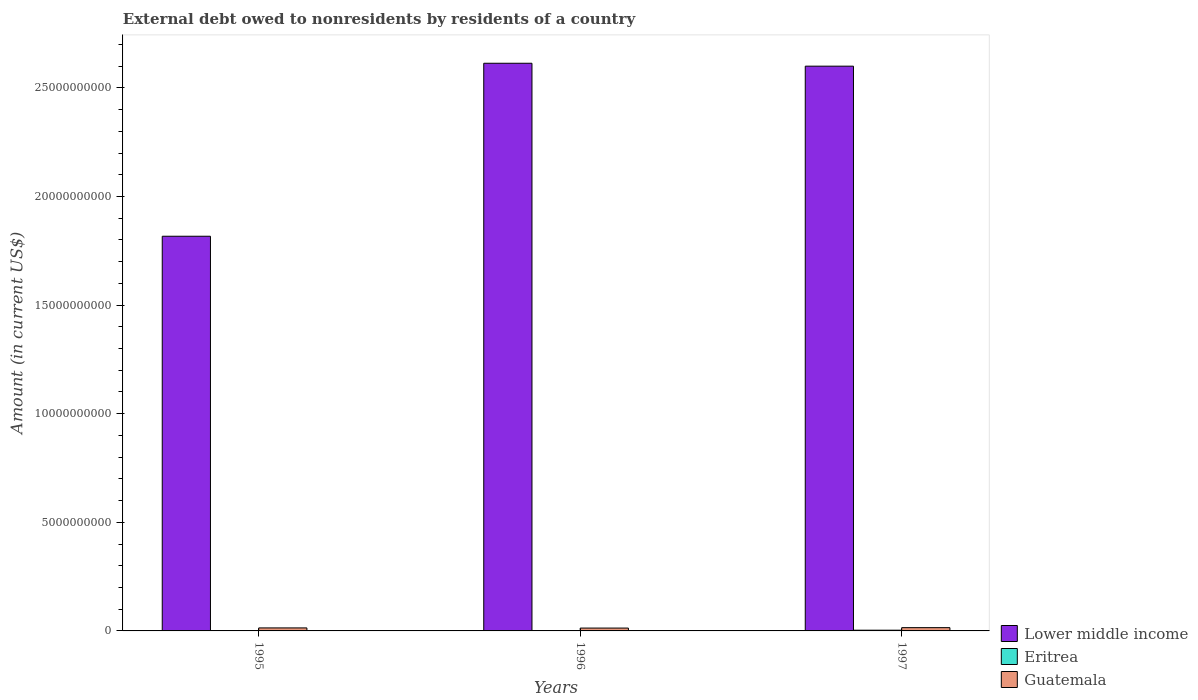How many groups of bars are there?
Your response must be concise. 3. Are the number of bars per tick equal to the number of legend labels?
Make the answer very short. Yes. How many bars are there on the 3rd tick from the left?
Your answer should be compact. 3. How many bars are there on the 2nd tick from the right?
Provide a short and direct response. 3. In how many cases, is the number of bars for a given year not equal to the number of legend labels?
Provide a short and direct response. 0. What is the external debt owed by residents in Guatemala in 1997?
Offer a terse response. 1.51e+08. Across all years, what is the maximum external debt owed by residents in Eritrea?
Give a very brief answer. 3.33e+07. Across all years, what is the minimum external debt owed by residents in Eritrea?
Keep it short and to the point. 6.93e+06. What is the total external debt owed by residents in Lower middle income in the graph?
Your answer should be compact. 7.03e+1. What is the difference between the external debt owed by residents in Lower middle income in 1995 and that in 1996?
Make the answer very short. -7.96e+09. What is the difference between the external debt owed by residents in Lower middle income in 1997 and the external debt owed by residents in Guatemala in 1995?
Give a very brief answer. 2.59e+1. What is the average external debt owed by residents in Lower middle income per year?
Give a very brief answer. 2.34e+1. In the year 1996, what is the difference between the external debt owed by residents in Lower middle income and external debt owed by residents in Eritrea?
Offer a terse response. 2.61e+1. What is the ratio of the external debt owed by residents in Guatemala in 1995 to that in 1997?
Make the answer very short. 0.92. What is the difference between the highest and the second highest external debt owed by residents in Lower middle income?
Provide a short and direct response. 1.34e+08. What is the difference between the highest and the lowest external debt owed by residents in Eritrea?
Provide a short and direct response. 2.64e+07. In how many years, is the external debt owed by residents in Lower middle income greater than the average external debt owed by residents in Lower middle income taken over all years?
Offer a very short reply. 2. Is the sum of the external debt owed by residents in Lower middle income in 1996 and 1997 greater than the maximum external debt owed by residents in Guatemala across all years?
Provide a short and direct response. Yes. What does the 2nd bar from the left in 1997 represents?
Ensure brevity in your answer.  Eritrea. What does the 1st bar from the right in 1996 represents?
Your response must be concise. Guatemala. Is it the case that in every year, the sum of the external debt owed by residents in Lower middle income and external debt owed by residents in Guatemala is greater than the external debt owed by residents in Eritrea?
Offer a terse response. Yes. How many years are there in the graph?
Give a very brief answer. 3. Are the values on the major ticks of Y-axis written in scientific E-notation?
Ensure brevity in your answer.  No. Does the graph contain grids?
Make the answer very short. No. What is the title of the graph?
Give a very brief answer. External debt owed to nonresidents by residents of a country. What is the label or title of the X-axis?
Your answer should be compact. Years. What is the label or title of the Y-axis?
Give a very brief answer. Amount (in current US$). What is the Amount (in current US$) of Lower middle income in 1995?
Your response must be concise. 1.82e+1. What is the Amount (in current US$) in Eritrea in 1995?
Your answer should be compact. 7.22e+06. What is the Amount (in current US$) of Guatemala in 1995?
Your response must be concise. 1.39e+08. What is the Amount (in current US$) in Lower middle income in 1996?
Keep it short and to the point. 2.61e+1. What is the Amount (in current US$) in Eritrea in 1996?
Offer a terse response. 6.93e+06. What is the Amount (in current US$) in Guatemala in 1996?
Provide a short and direct response. 1.31e+08. What is the Amount (in current US$) in Lower middle income in 1997?
Keep it short and to the point. 2.60e+1. What is the Amount (in current US$) of Eritrea in 1997?
Keep it short and to the point. 3.33e+07. What is the Amount (in current US$) of Guatemala in 1997?
Offer a very short reply. 1.51e+08. Across all years, what is the maximum Amount (in current US$) in Lower middle income?
Your response must be concise. 2.61e+1. Across all years, what is the maximum Amount (in current US$) in Eritrea?
Offer a very short reply. 3.33e+07. Across all years, what is the maximum Amount (in current US$) in Guatemala?
Offer a very short reply. 1.51e+08. Across all years, what is the minimum Amount (in current US$) in Lower middle income?
Your answer should be compact. 1.82e+1. Across all years, what is the minimum Amount (in current US$) of Eritrea?
Your answer should be very brief. 6.93e+06. Across all years, what is the minimum Amount (in current US$) in Guatemala?
Your answer should be very brief. 1.31e+08. What is the total Amount (in current US$) of Lower middle income in the graph?
Give a very brief answer. 7.03e+1. What is the total Amount (in current US$) of Eritrea in the graph?
Provide a succinct answer. 4.75e+07. What is the total Amount (in current US$) in Guatemala in the graph?
Your response must be concise. 4.21e+08. What is the difference between the Amount (in current US$) in Lower middle income in 1995 and that in 1996?
Offer a terse response. -7.96e+09. What is the difference between the Amount (in current US$) of Eritrea in 1995 and that in 1996?
Keep it short and to the point. 2.91e+05. What is the difference between the Amount (in current US$) in Guatemala in 1995 and that in 1996?
Your answer should be compact. 7.50e+06. What is the difference between the Amount (in current US$) of Lower middle income in 1995 and that in 1997?
Make the answer very short. -7.83e+09. What is the difference between the Amount (in current US$) of Eritrea in 1995 and that in 1997?
Your answer should be compact. -2.61e+07. What is the difference between the Amount (in current US$) in Guatemala in 1995 and that in 1997?
Your response must be concise. -1.24e+07. What is the difference between the Amount (in current US$) in Lower middle income in 1996 and that in 1997?
Give a very brief answer. 1.34e+08. What is the difference between the Amount (in current US$) of Eritrea in 1996 and that in 1997?
Make the answer very short. -2.64e+07. What is the difference between the Amount (in current US$) in Guatemala in 1996 and that in 1997?
Ensure brevity in your answer.  -1.99e+07. What is the difference between the Amount (in current US$) of Lower middle income in 1995 and the Amount (in current US$) of Eritrea in 1996?
Provide a short and direct response. 1.82e+1. What is the difference between the Amount (in current US$) in Lower middle income in 1995 and the Amount (in current US$) in Guatemala in 1996?
Your response must be concise. 1.80e+1. What is the difference between the Amount (in current US$) of Eritrea in 1995 and the Amount (in current US$) of Guatemala in 1996?
Provide a succinct answer. -1.24e+08. What is the difference between the Amount (in current US$) in Lower middle income in 1995 and the Amount (in current US$) in Eritrea in 1997?
Give a very brief answer. 1.81e+1. What is the difference between the Amount (in current US$) in Lower middle income in 1995 and the Amount (in current US$) in Guatemala in 1997?
Offer a terse response. 1.80e+1. What is the difference between the Amount (in current US$) in Eritrea in 1995 and the Amount (in current US$) in Guatemala in 1997?
Your answer should be compact. -1.44e+08. What is the difference between the Amount (in current US$) of Lower middle income in 1996 and the Amount (in current US$) of Eritrea in 1997?
Provide a short and direct response. 2.61e+1. What is the difference between the Amount (in current US$) in Lower middle income in 1996 and the Amount (in current US$) in Guatemala in 1997?
Give a very brief answer. 2.60e+1. What is the difference between the Amount (in current US$) of Eritrea in 1996 and the Amount (in current US$) of Guatemala in 1997?
Offer a very short reply. -1.44e+08. What is the average Amount (in current US$) in Lower middle income per year?
Keep it short and to the point. 2.34e+1. What is the average Amount (in current US$) in Eritrea per year?
Your answer should be very brief. 1.58e+07. What is the average Amount (in current US$) of Guatemala per year?
Your answer should be very brief. 1.40e+08. In the year 1995, what is the difference between the Amount (in current US$) of Lower middle income and Amount (in current US$) of Eritrea?
Ensure brevity in your answer.  1.82e+1. In the year 1995, what is the difference between the Amount (in current US$) in Lower middle income and Amount (in current US$) in Guatemala?
Make the answer very short. 1.80e+1. In the year 1995, what is the difference between the Amount (in current US$) of Eritrea and Amount (in current US$) of Guatemala?
Provide a succinct answer. -1.31e+08. In the year 1996, what is the difference between the Amount (in current US$) in Lower middle income and Amount (in current US$) in Eritrea?
Keep it short and to the point. 2.61e+1. In the year 1996, what is the difference between the Amount (in current US$) of Lower middle income and Amount (in current US$) of Guatemala?
Provide a short and direct response. 2.60e+1. In the year 1996, what is the difference between the Amount (in current US$) of Eritrea and Amount (in current US$) of Guatemala?
Provide a short and direct response. -1.24e+08. In the year 1997, what is the difference between the Amount (in current US$) in Lower middle income and Amount (in current US$) in Eritrea?
Your answer should be compact. 2.60e+1. In the year 1997, what is the difference between the Amount (in current US$) in Lower middle income and Amount (in current US$) in Guatemala?
Provide a short and direct response. 2.58e+1. In the year 1997, what is the difference between the Amount (in current US$) of Eritrea and Amount (in current US$) of Guatemala?
Offer a terse response. -1.18e+08. What is the ratio of the Amount (in current US$) in Lower middle income in 1995 to that in 1996?
Keep it short and to the point. 0.7. What is the ratio of the Amount (in current US$) in Eritrea in 1995 to that in 1996?
Keep it short and to the point. 1.04. What is the ratio of the Amount (in current US$) in Guatemala in 1995 to that in 1996?
Give a very brief answer. 1.06. What is the ratio of the Amount (in current US$) in Lower middle income in 1995 to that in 1997?
Offer a terse response. 0.7. What is the ratio of the Amount (in current US$) of Eritrea in 1995 to that in 1997?
Offer a very short reply. 0.22. What is the ratio of the Amount (in current US$) in Guatemala in 1995 to that in 1997?
Keep it short and to the point. 0.92. What is the ratio of the Amount (in current US$) of Lower middle income in 1996 to that in 1997?
Keep it short and to the point. 1.01. What is the ratio of the Amount (in current US$) in Eritrea in 1996 to that in 1997?
Offer a terse response. 0.21. What is the ratio of the Amount (in current US$) of Guatemala in 1996 to that in 1997?
Your answer should be very brief. 0.87. What is the difference between the highest and the second highest Amount (in current US$) in Lower middle income?
Provide a succinct answer. 1.34e+08. What is the difference between the highest and the second highest Amount (in current US$) in Eritrea?
Your answer should be very brief. 2.61e+07. What is the difference between the highest and the second highest Amount (in current US$) in Guatemala?
Keep it short and to the point. 1.24e+07. What is the difference between the highest and the lowest Amount (in current US$) in Lower middle income?
Your answer should be compact. 7.96e+09. What is the difference between the highest and the lowest Amount (in current US$) of Eritrea?
Provide a succinct answer. 2.64e+07. What is the difference between the highest and the lowest Amount (in current US$) in Guatemala?
Ensure brevity in your answer.  1.99e+07. 